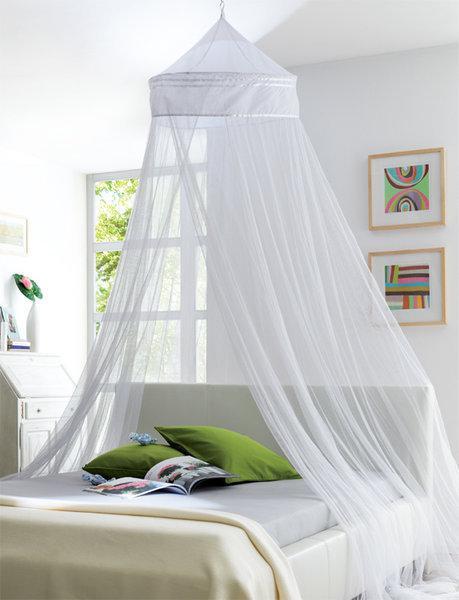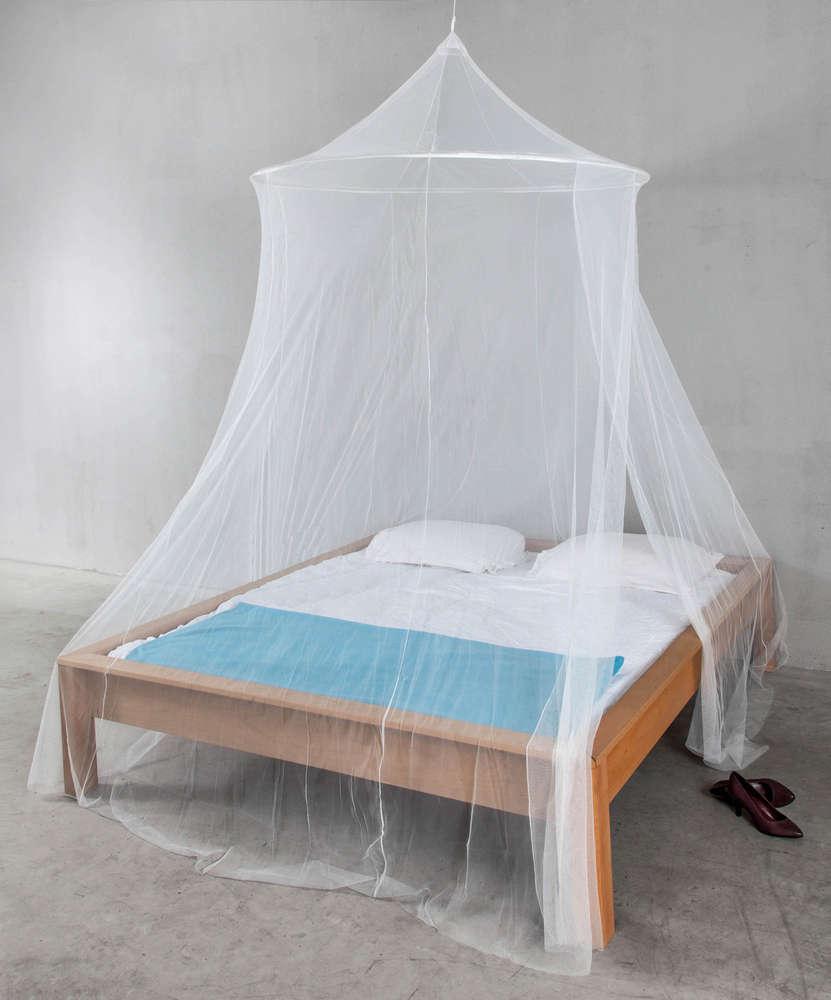The first image is the image on the left, the second image is the image on the right. For the images shown, is this caption "The left and right image contains the same number of canopies one circle and one square." true? Answer yes or no. No. The first image is the image on the left, the second image is the image on the right. Given the left and right images, does the statement "There is exactly one round canopy." hold true? Answer yes or no. No. 